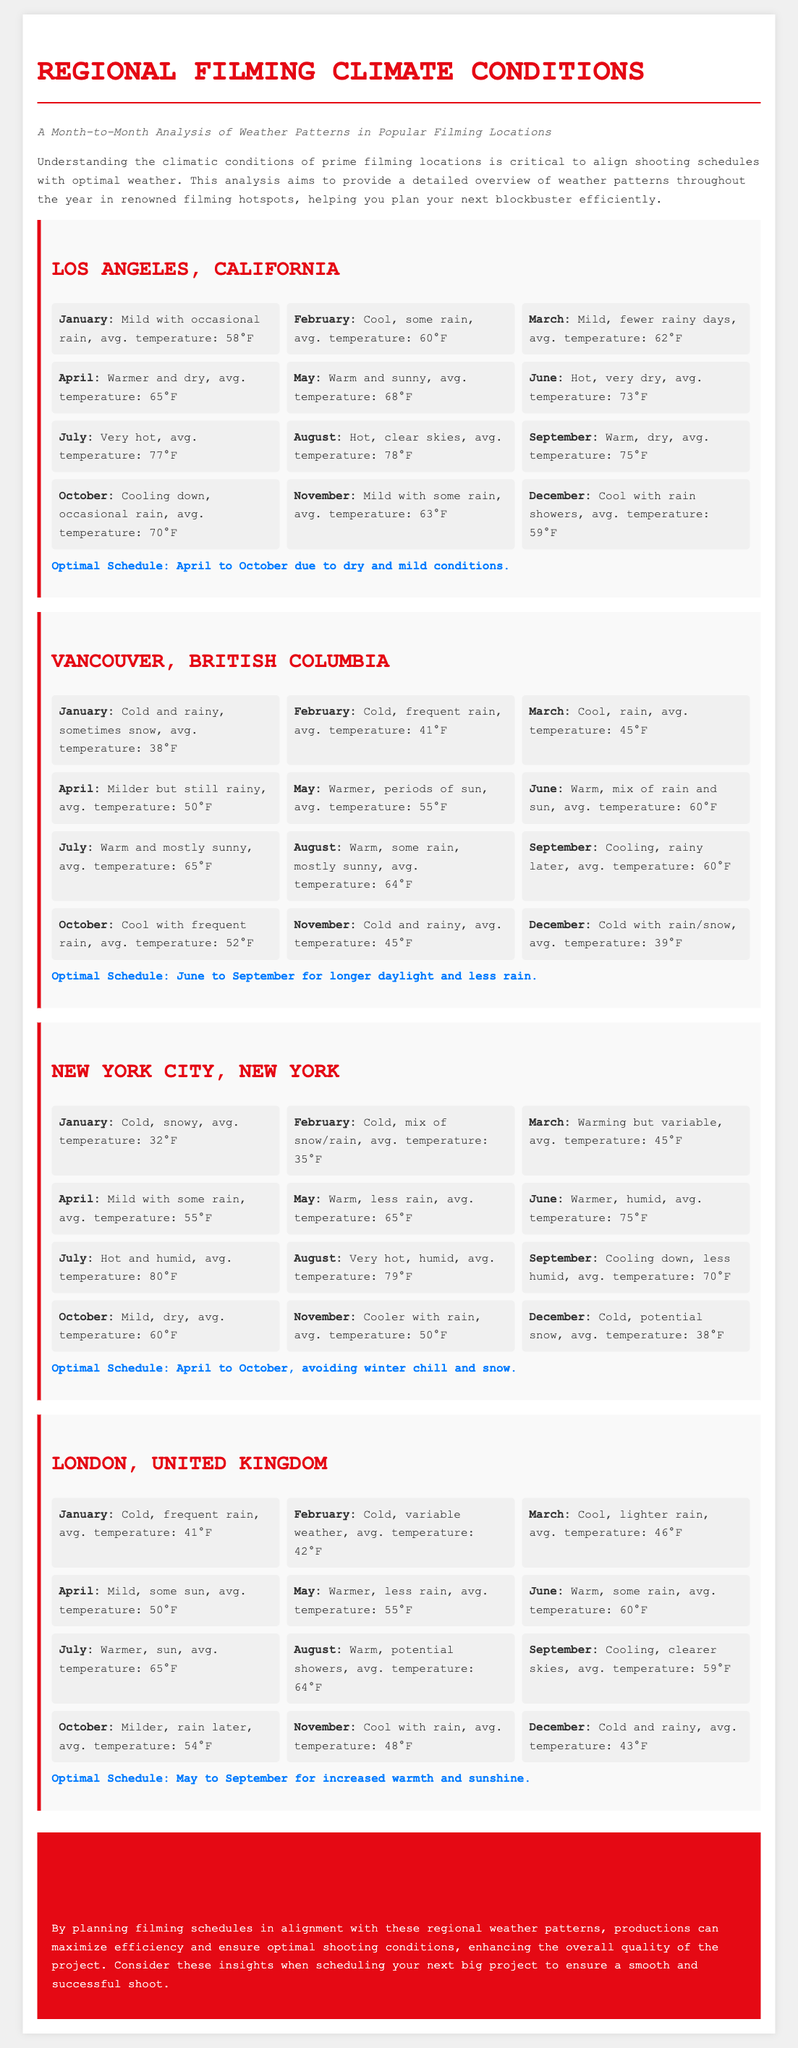What is the average temperature in Los Angeles for July? The average temperature in Los Angeles for July is mentioned as 77°F in the document.
Answer: 77°F What is the optimal filming schedule for Vancouver? The document states that the optimal filming schedule for Vancouver is June to September due to longer daylight and less rain.
Answer: June to September Which month in New York City is the coldest? January is noted as the coldest month in New York City with an average temperature of 32°F.
Answer: January What is the average temperature in London for May? The document specifies that the average temperature in London for May is 55°F.
Answer: 55°F How many months are optimal for filming in Los Angeles? The document mentions an optimal filming schedule spanning from April to October, which is 7 months in total.
Answer: 7 months What is the average temperature in Vancouver for December? The average temperature in Vancouver for December is stated as 39°F in the document.
Answer: 39°F What weather condition is prevalent in London during January? The document indicates that London encounters cold and frequent rain in January.
Answer: Cold and frequent rain Which month has the highest average temperature in New York City? The highest average temperature in New York City is observed in July, at 80°F.
Answer: July What month is optimal for filming in London? The document states that the optimal filming schedule for London is from May to September.
Answer: May to September 